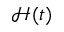Convert formula to latex. <formula><loc_0><loc_0><loc_500><loc_500>\mathcal { H } ( t )</formula> 